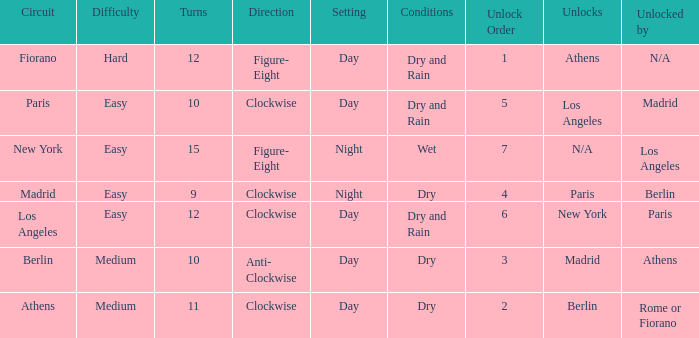How many instances is paris the unlock? 1.0. 